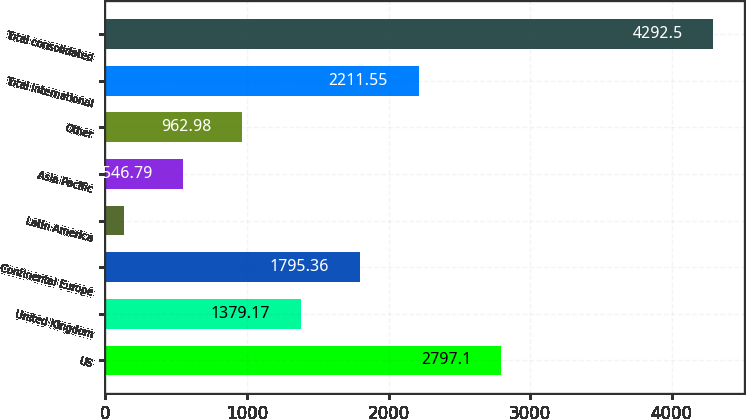<chart> <loc_0><loc_0><loc_500><loc_500><bar_chart><fcel>US<fcel>United Kingdom<fcel>Continental Europe<fcel>Latin America<fcel>Asia Pacific<fcel>Other<fcel>Total international<fcel>Total consolidated<nl><fcel>2797.1<fcel>1379.17<fcel>1795.36<fcel>130.6<fcel>546.79<fcel>962.98<fcel>2211.55<fcel>4292.5<nl></chart> 